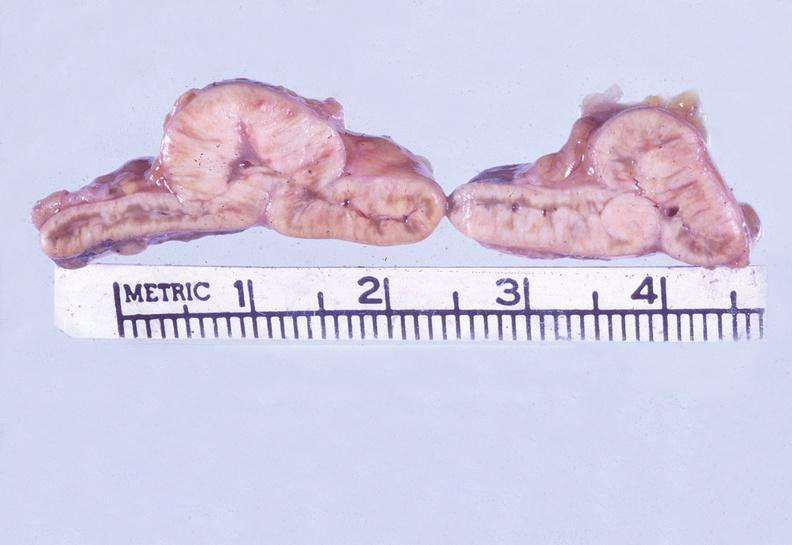where does this belong to?
Answer the question using a single word or phrase. Endocrine system 